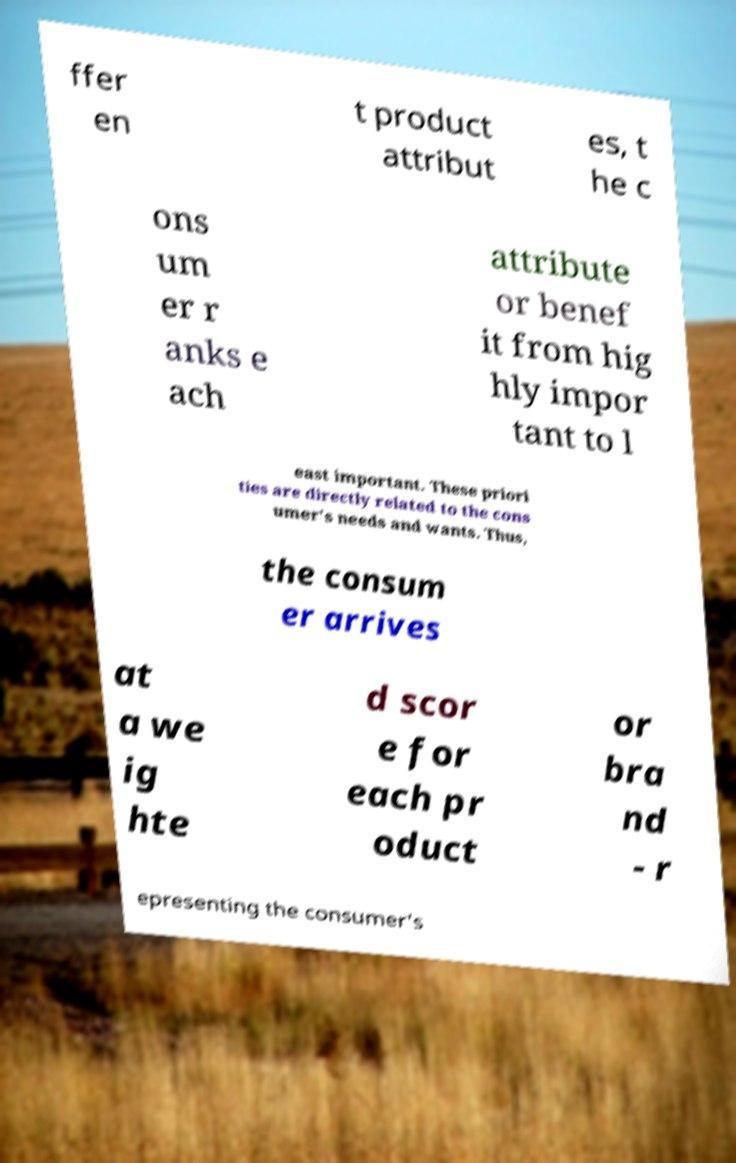Can you accurately transcribe the text from the provided image for me? ffer en t product attribut es, t he c ons um er r anks e ach attribute or benef it from hig hly impor tant to l east important. These priori ties are directly related to the cons umer's needs and wants. Thus, the consum er arrives at a we ig hte d scor e for each pr oduct or bra nd - r epresenting the consumer's 